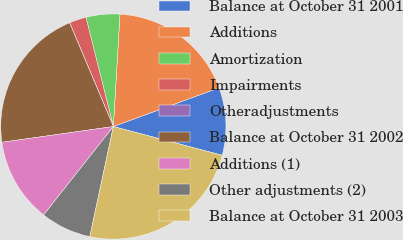<chart> <loc_0><loc_0><loc_500><loc_500><pie_chart><fcel>Balance at October 31 2001<fcel>Additions<fcel>Amortization<fcel>Impairments<fcel>Otheradjustments<fcel>Balance at October 31 2002<fcel>Additions (1)<fcel>Other adjustments (2)<fcel>Balance at October 31 2003<nl><fcel>9.7%<fcel>18.47%<fcel>4.85%<fcel>2.43%<fcel>0.0%<fcel>20.89%<fcel>12.13%<fcel>7.28%<fcel>24.25%<nl></chart> 